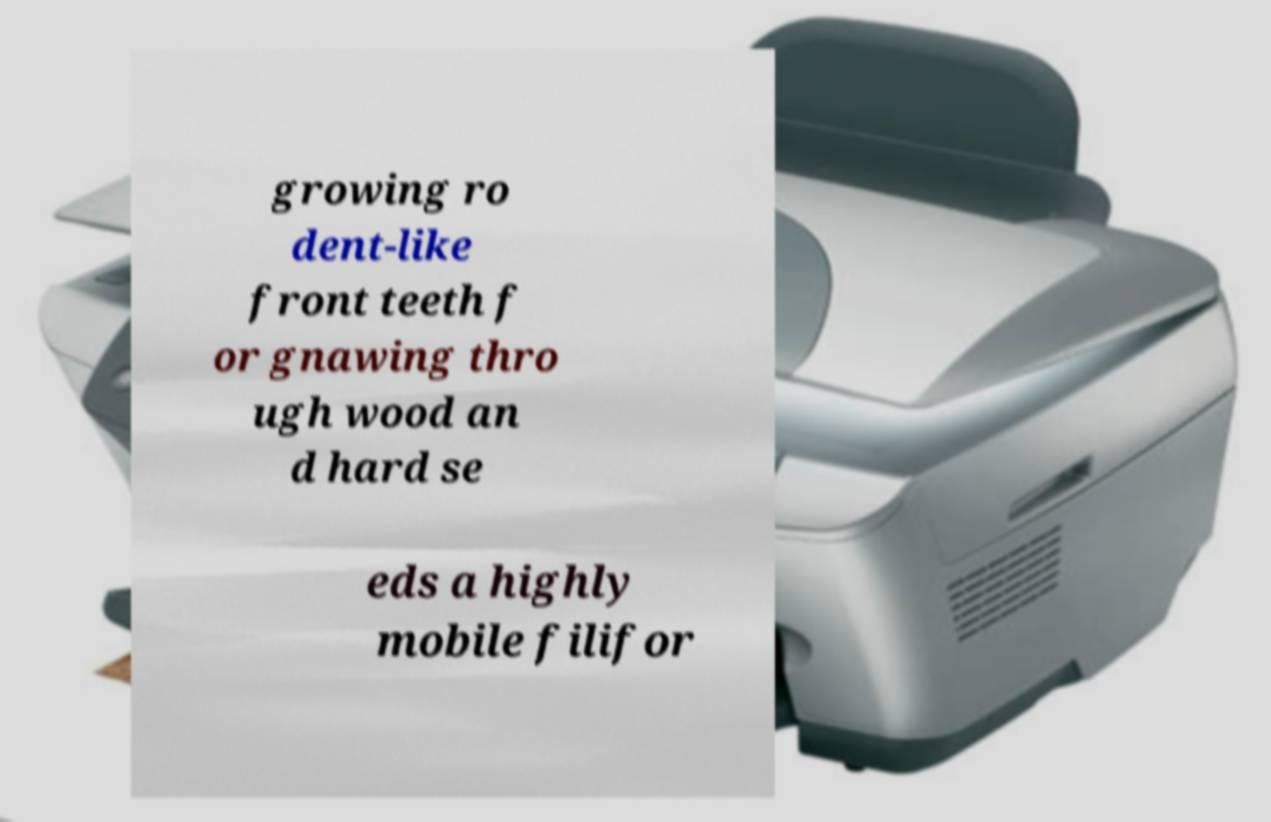Could you extract and type out the text from this image? growing ro dent-like front teeth f or gnawing thro ugh wood an d hard se eds a highly mobile filifor 